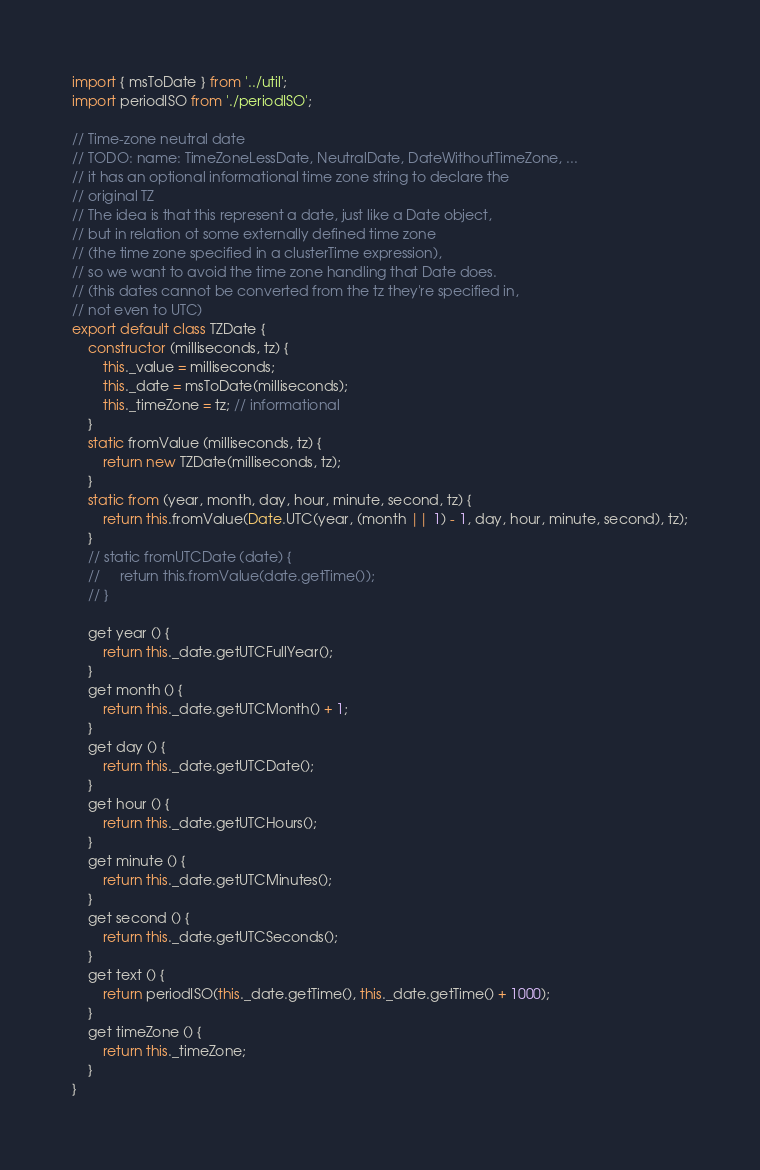<code> <loc_0><loc_0><loc_500><loc_500><_JavaScript_>import { msToDate } from '../util';
import periodISO from './periodISO';

// Time-zone neutral date
// TODO: name: TimeZoneLessDate, NeutralDate, DateWithoutTimeZone, ...
// it has an optional informational time zone string to declare the
// original TZ
// The idea is that this represent a date, just like a Date object,
// but in relation ot some externally defined time zone
// (the time zone specified in a clusterTime expression),
// so we want to avoid the time zone handling that Date does.
// (this dates cannot be converted from the tz they're specified in,
// not even to UTC)
export default class TZDate {
    constructor (milliseconds, tz) {
        this._value = milliseconds;
        this._date = msToDate(milliseconds);
        this._timeZone = tz; // informational
    }
    static fromValue (milliseconds, tz) {
        return new TZDate(milliseconds, tz);
    }
    static from (year, month, day, hour, minute, second, tz) {
        return this.fromValue(Date.UTC(year, (month || 1) - 1, day, hour, minute, second), tz);
    }
    // static fromUTCDate (date) {
    //     return this.fromValue(date.getTime());
    // }

    get year () {
        return this._date.getUTCFullYear();
    }
    get month () {
        return this._date.getUTCMonth() + 1;
    }
    get day () {
        return this._date.getUTCDate();
    }
    get hour () {
        return this._date.getUTCHours();
    }
    get minute () {
        return this._date.getUTCMinutes();
    }
    get second () {
        return this._date.getUTCSeconds();
    }
    get text () {
        return periodISO(this._date.getTime(), this._date.getTime() + 1000);
    }
    get timeZone () {
        return this._timeZone;
    }
}
</code> 